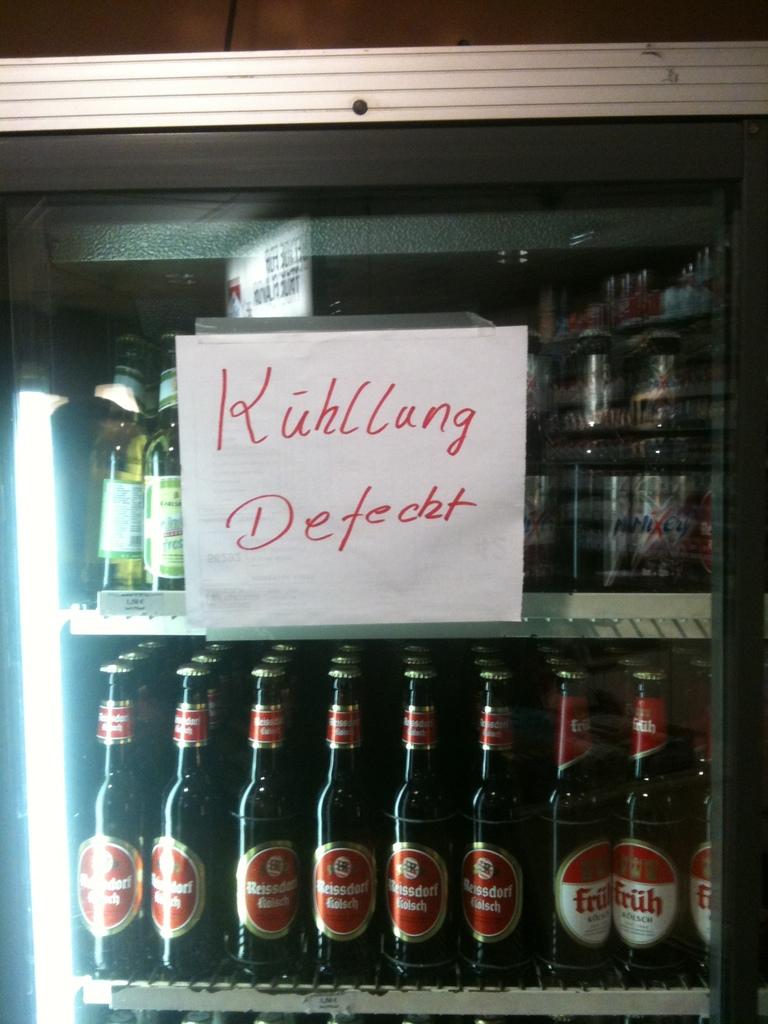What does the sign say on the cooler?
Make the answer very short. Kuhllung defecht. What kind of beer is on the bottom right?
Keep it short and to the point. Fruh. 